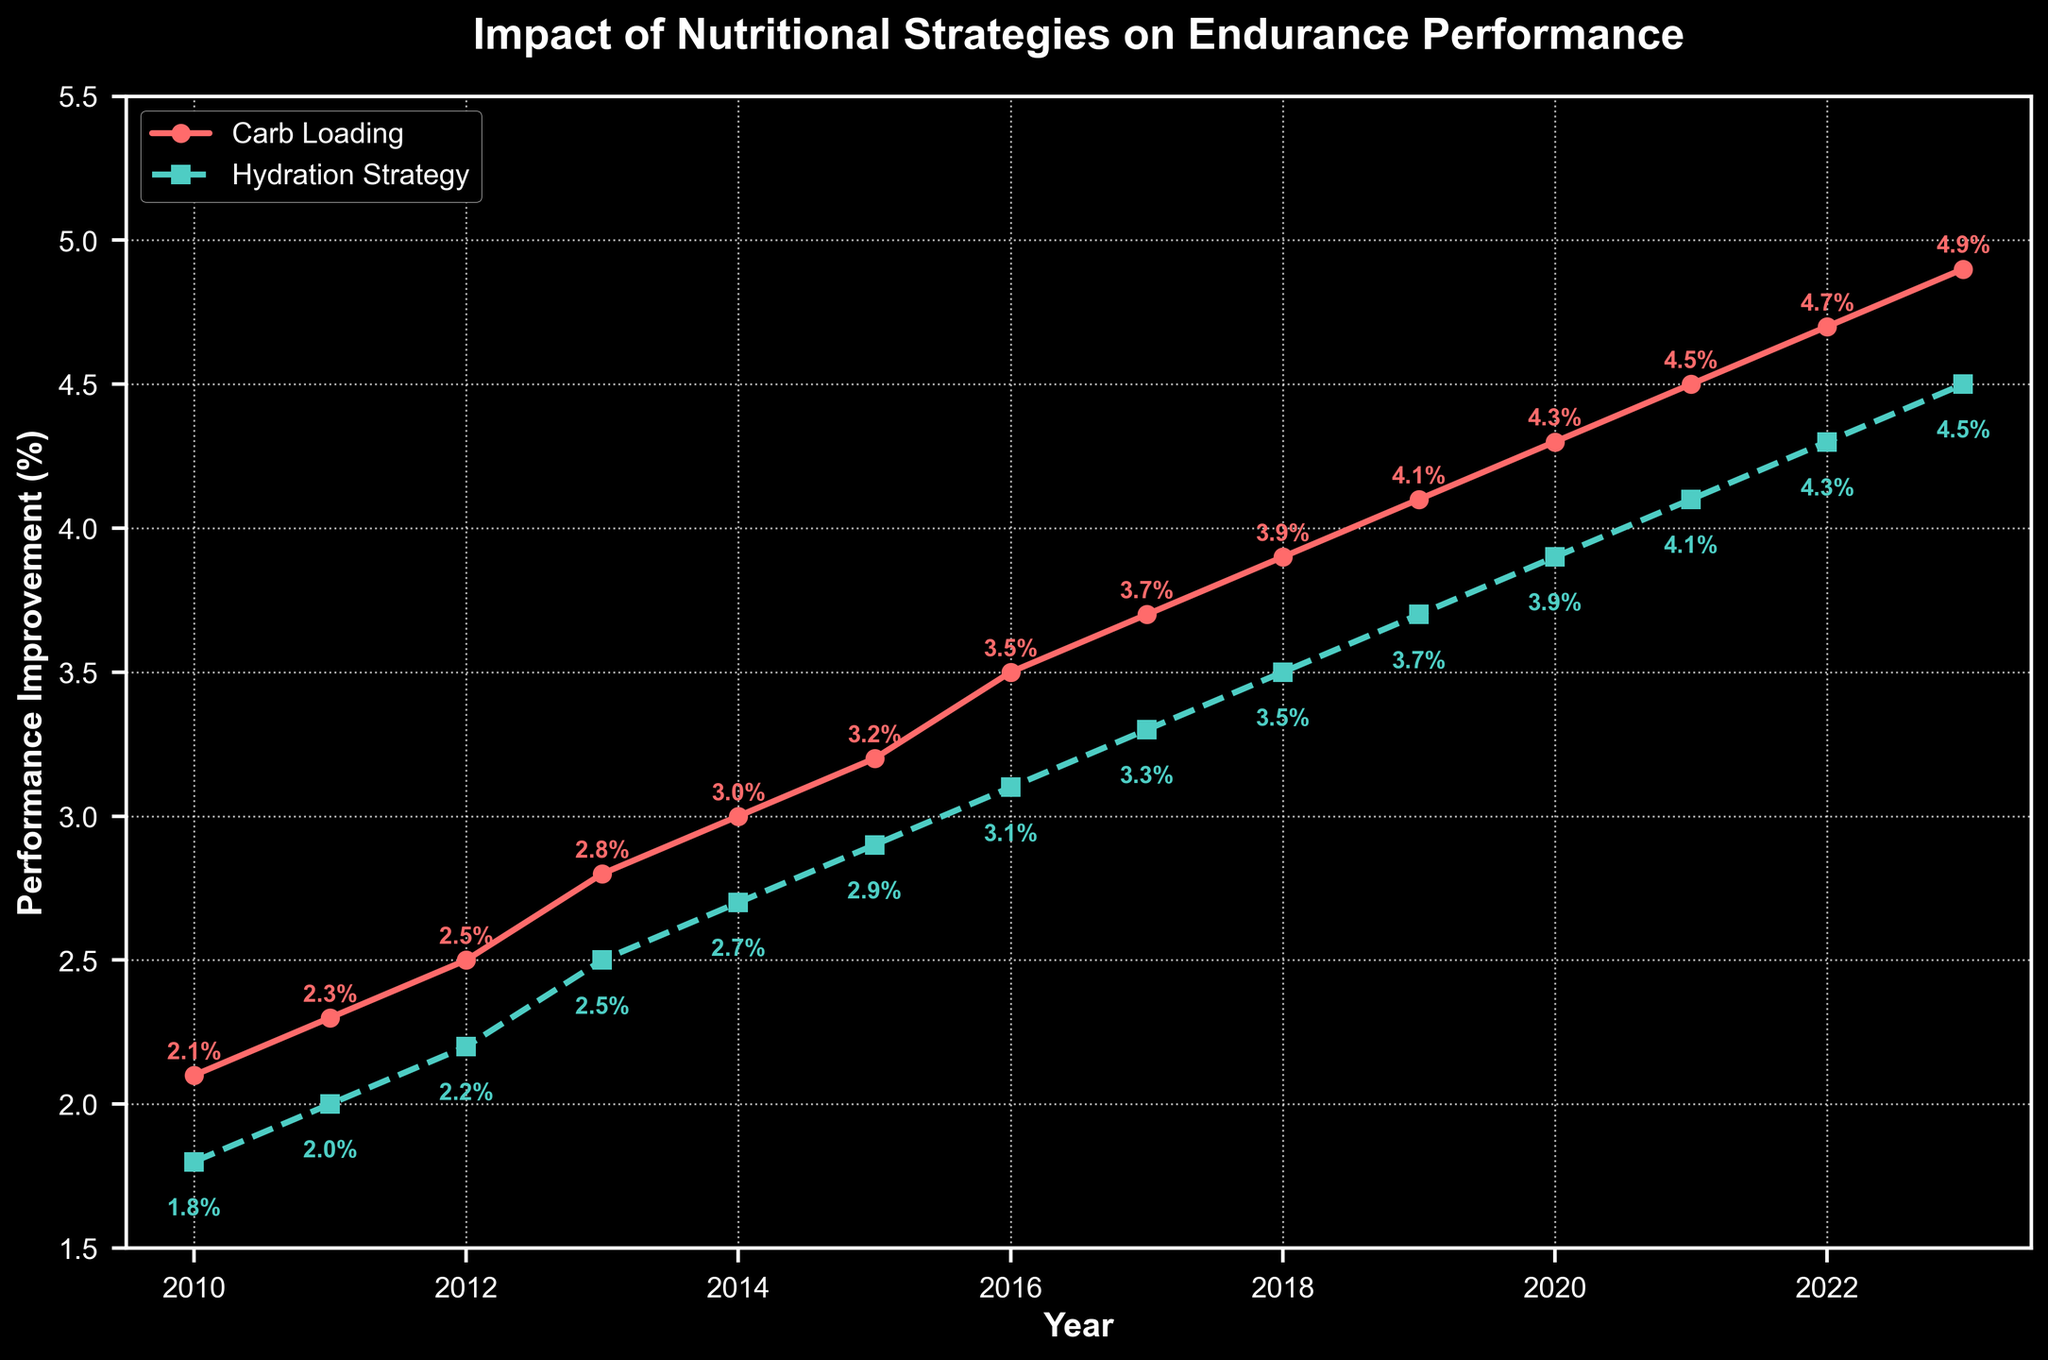Which year shows the highest performance improvement for carb loading? The line representing carb loading shows an upward trend, and the highest value appears at the rightmost end of the line. The year corresponding to this value is 2023.
Answer: 2023 How does the performance improvement in hydration strategy compare between 2011 and 2015? The value for hydration strategy in 2011 is 2.0%, and in 2015 it is 2.9%. Comparing these, 2.9% is greater than 2.0%.
Answer: 2.9% is greater than 2.0% What is the average performance improvement for carb loading from 2010 to 2013? The performance improvements for carb loading from 2010 to 2013 are 2.1%, 2.3%, 2.5%, and 2.8%. Summing these, we get 9.7. Dividing by 4 gives an average of 2.425%.
Answer: 2.425% By how much did the performance improvement in carb loading increase from 2010 to 2023? The performance improvement in carb loading in 2010 is 2.1%, and in 2023 it is 4.9%. The increase is 4.9% - 2.1% = 2.8%.
Answer: 2.8% Compare the overall trend for performance improvement between carb loading and hydration strategy from 2010 to 2023. Both carb loading and hydration strategy show an increasing trend from 2010 to 2023. However, the slope for carb loading is steeper, indicating a faster rate of improvement.
Answer: Both increase, but carb loading increases faster For which years is the performance improvement for carb loading exactly 1% higher than for the hydration strategy? Looking year-by-year, we find the performance improvements for each strategy. The years where carb loading improvement is 1% higher than hydration strategy are 2015 (3.2% - 2.9%), and 2016 (3.5% - 3.1%).
Answer: 2015, 2016 What is the total sum of performance improvement percentages for hydration strategy from 2010 to 2023? Adding the values for hydration strategy from 2010 to 2023 gives: 1.8 + 2.0 + 2.2 + 2.5 + 2.7 + 2.9 + 3.1 + 3.3 + 3.5 + 3.7 + 3.9 + 4.1 + 4.3 + 4.5 = 40.6%.
Answer: 40.6% In which year did both strategies show the smallest improvement? The smallest improvement for carb loading is 2.1% in 2010, and for hydration strategy, it is 1.8% also in 2010. Therefore, the year with the smallest improvement for both strategies is 2010.
Answer: 2010 From 2010 to 2023, in which year does the performance improvement for hydration strategy first exceed 3%? From the graph, hydration strategy first exceeds 3% in the year 2016, where the value is 3.1%.
Answer: 2016 